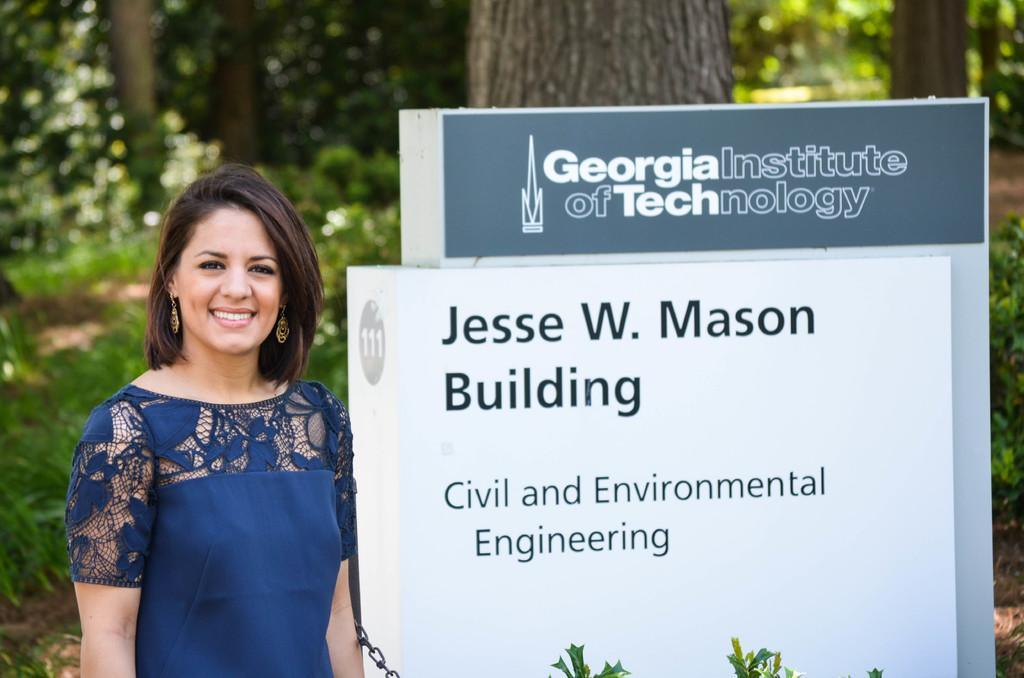Can you describe this image briefly? In this image we can see a woman wearing blue dress is stunning. In the background, we can see a signboard with some text on it and a group of trees. 